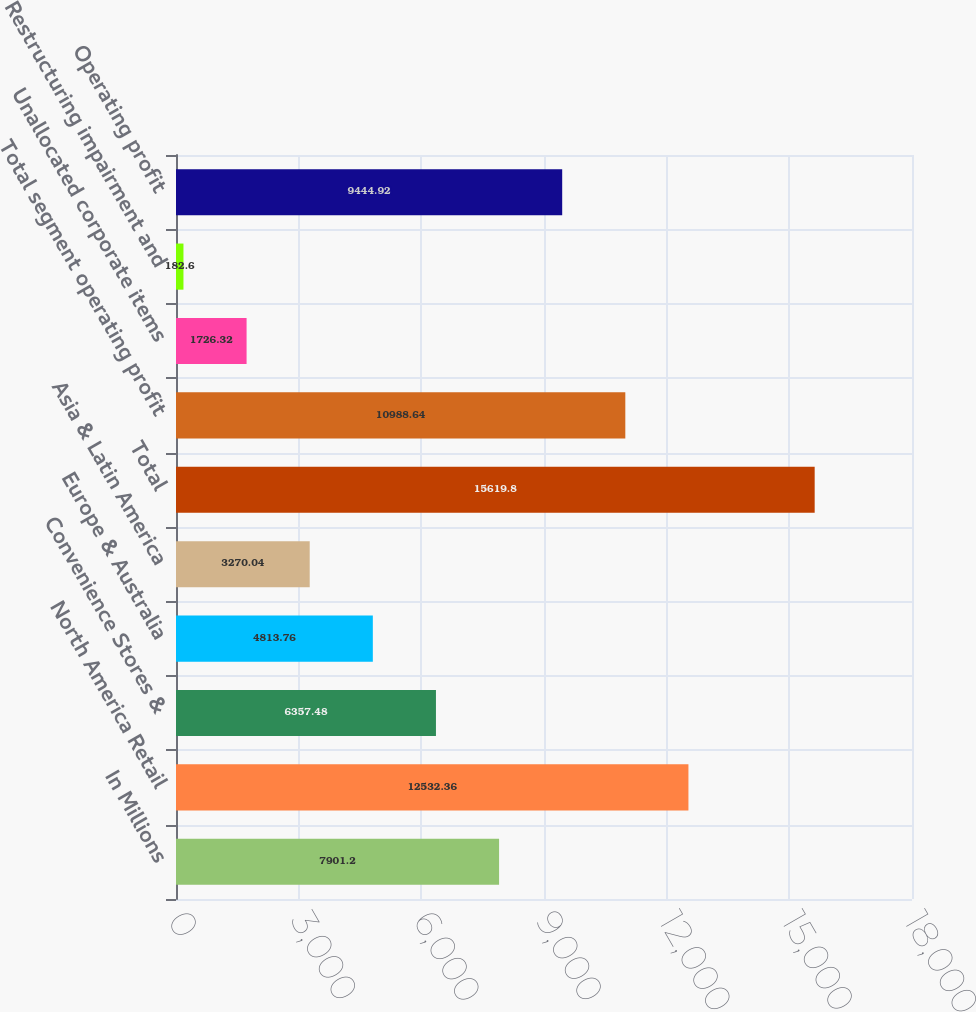Convert chart to OTSL. <chart><loc_0><loc_0><loc_500><loc_500><bar_chart><fcel>In Millions<fcel>North America Retail<fcel>Convenience Stores &<fcel>Europe & Australia<fcel>Asia & Latin America<fcel>Total<fcel>Total segment operating profit<fcel>Unallocated corporate items<fcel>Restructuring impairment and<fcel>Operating profit<nl><fcel>7901.2<fcel>12532.4<fcel>6357.48<fcel>4813.76<fcel>3270.04<fcel>15619.8<fcel>10988.6<fcel>1726.32<fcel>182.6<fcel>9444.92<nl></chart> 